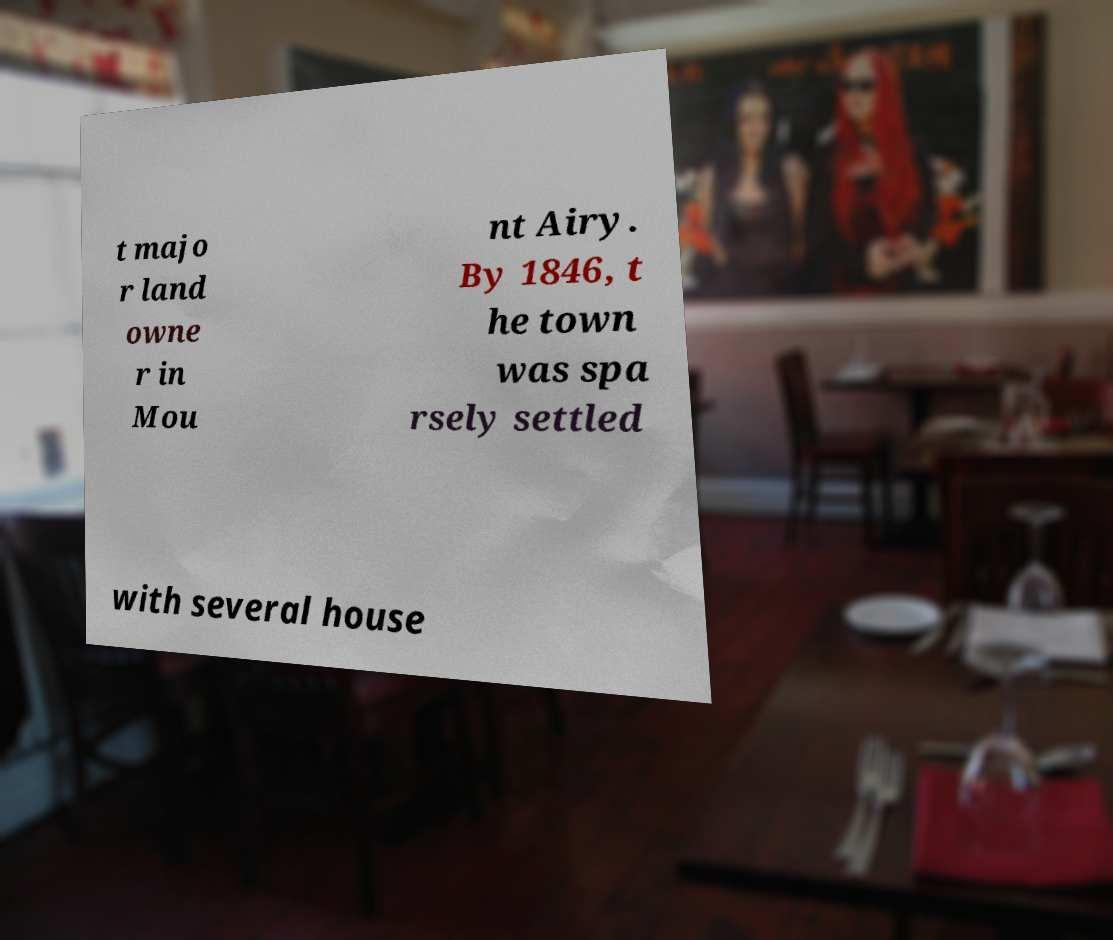What messages or text are displayed in this image? I need them in a readable, typed format. t majo r land owne r in Mou nt Airy. By 1846, t he town was spa rsely settled with several house 